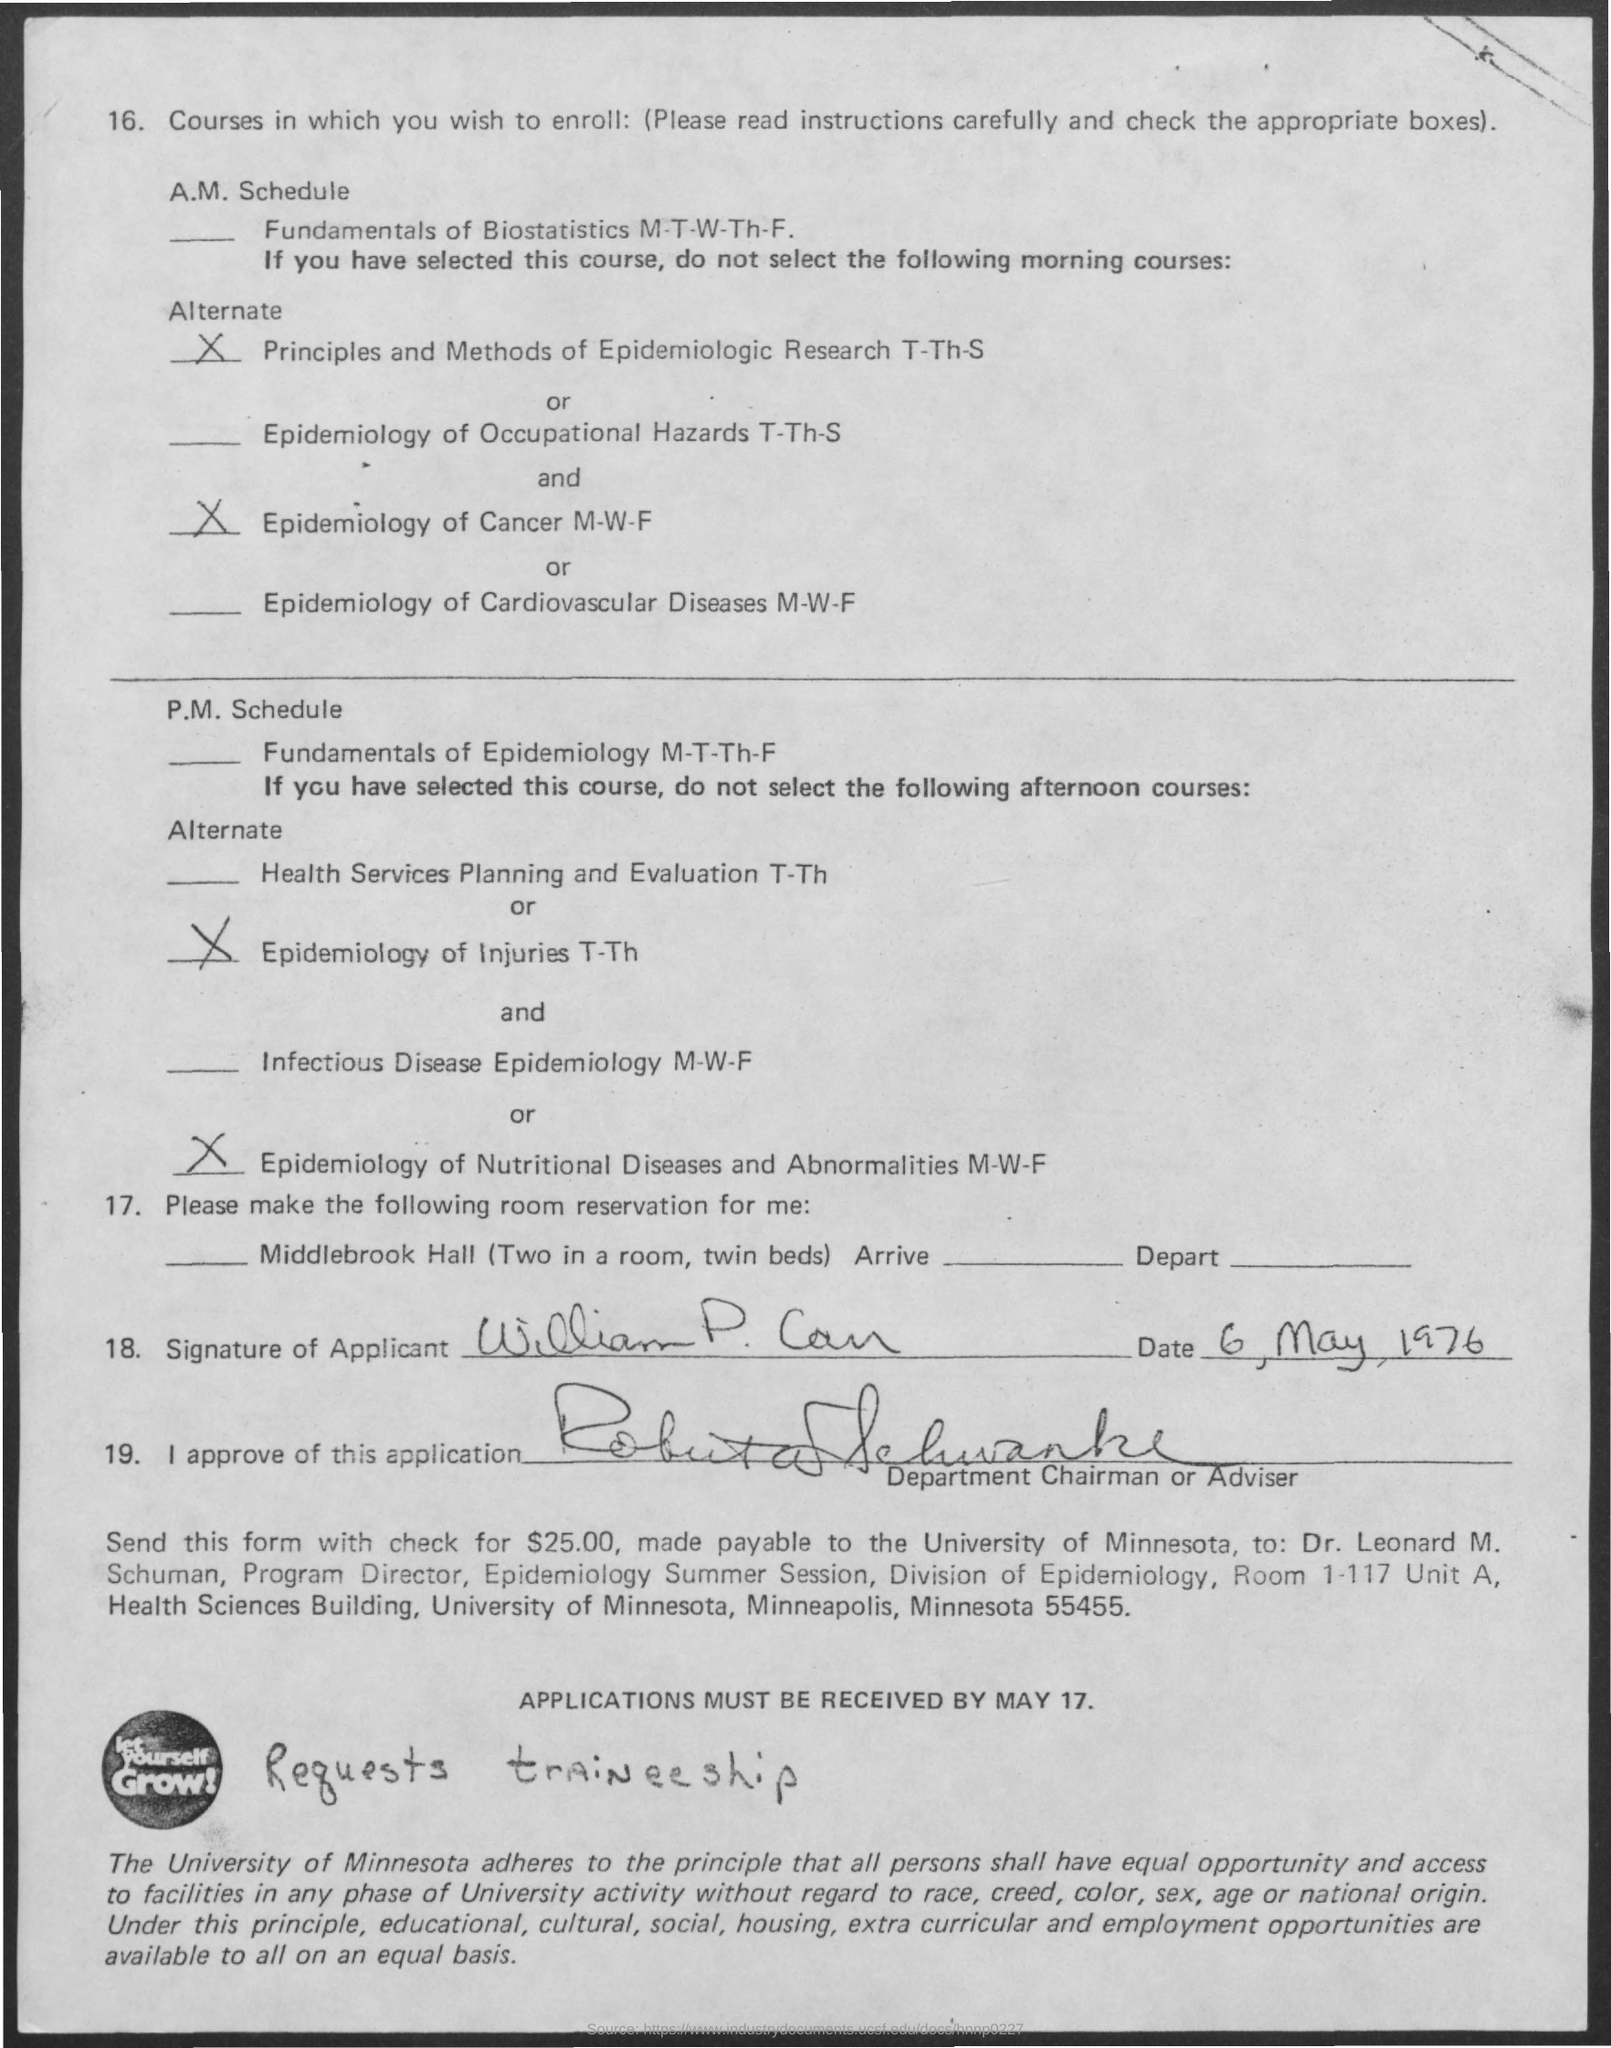List a handful of essential elements in this visual. The Epidemiology of Cancer Course will take place on Mondays, Wednesdays, and Fridays. The deadline for receiving applications is May 17th. 